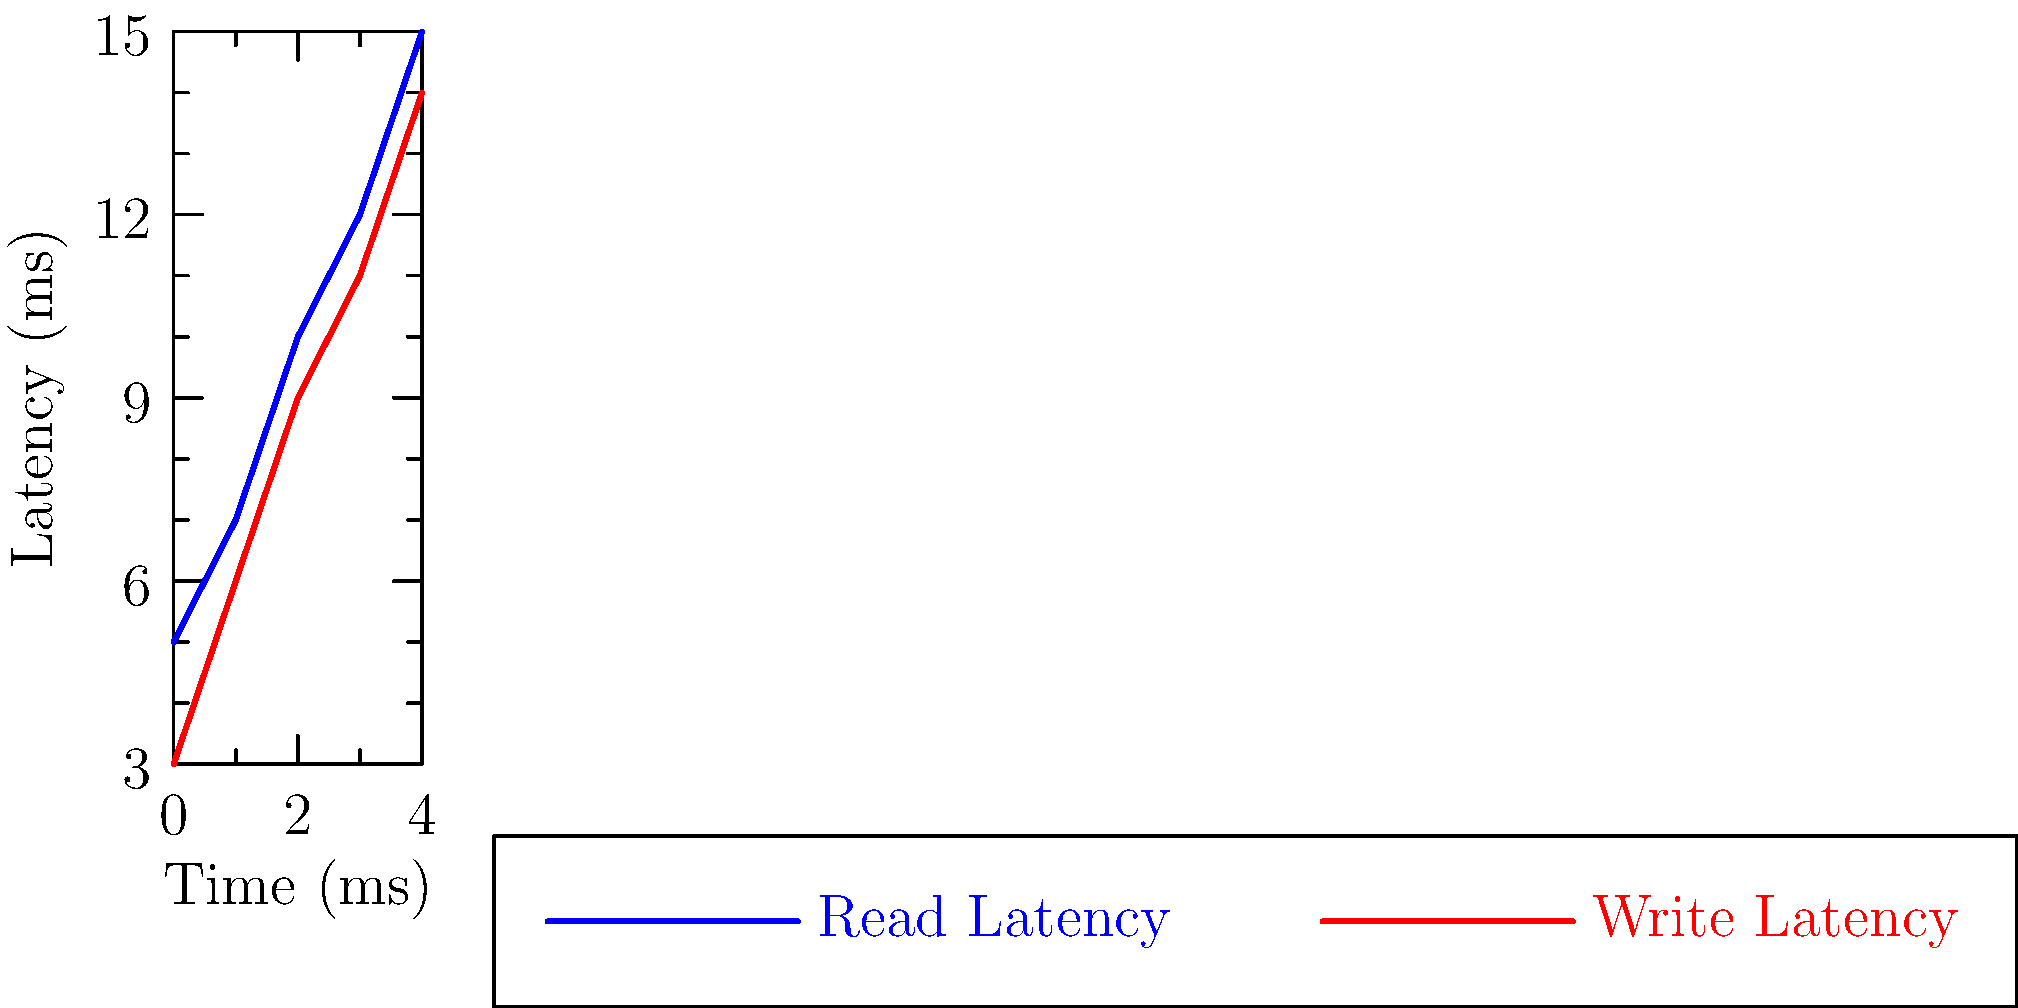Based on the line graph showing read and write latencies in Cassandra over time, which operation consistently exhibits higher latency, and what could be a potential reason for this difference in a typical Cassandra deployment? To answer this question, let's analyze the graph step-by-step:

1. Observe the two lines:
   - Blue line represents Read Latency
   - Red line represents Write Latency

2. Compare the positions of the lines:
   - The blue line (Read Latency) is consistently above the red line (Write Latency) throughout the time range.
   - This indicates that read operations consistently have higher latency than write operations.

3. Calculate the difference:
   - At each time point, the read latency is approximately 2-3 ms higher than the write latency.

4. Interpret the results:
   - In Cassandra, read operations often have higher latency due to the distributed nature of the database and its eventual consistency model.

5. Consider potential reasons:
   - Read operations may need to query multiple nodes to ensure consistency, especially if the consistency level is set higher than ONE.
   - The read repair process, which reconciles inconsistencies between replicas, can add overhead to read operations.
   - Write operations in Cassandra are typically faster because they can be immediately acknowledged after writing to the commit log and memtable, without waiting for all replicas to be updated.

6. Conclusion:
   - Read operations consistently exhibit higher latency in this Cassandra deployment.
   - This is likely due to the distributed nature of Cassandra and the potential need to query multiple nodes for read consistency.
Answer: Read operations; distributed nature and consistency requirements 